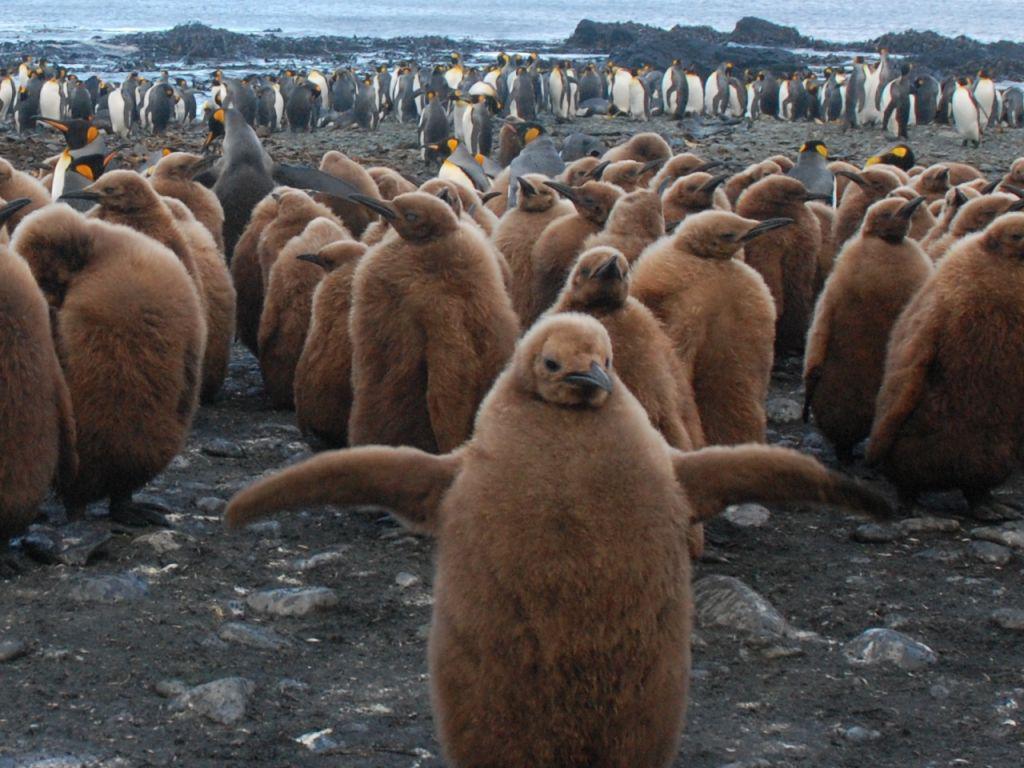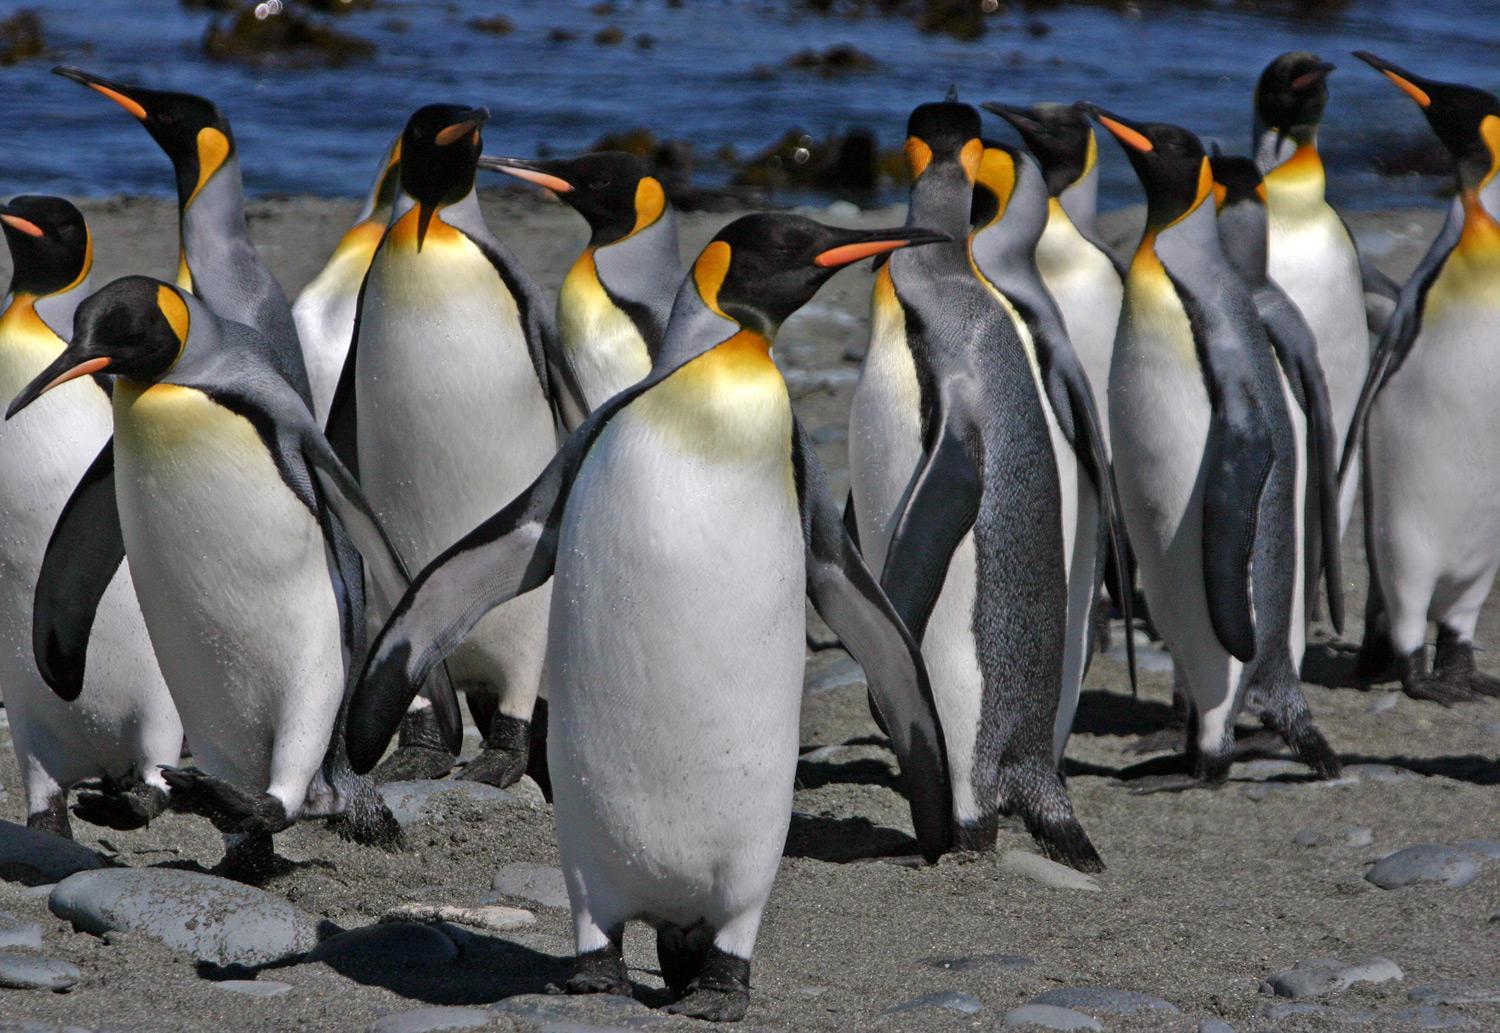The first image is the image on the left, the second image is the image on the right. For the images displayed, is the sentence "There is no more than one penguin in the left image." factually correct? Answer yes or no. No. The first image is the image on the left, the second image is the image on the right. Considering the images on both sides, is "A single black and white penguin with yellow markings stands alone in the image on the left." valid? Answer yes or no. No. 